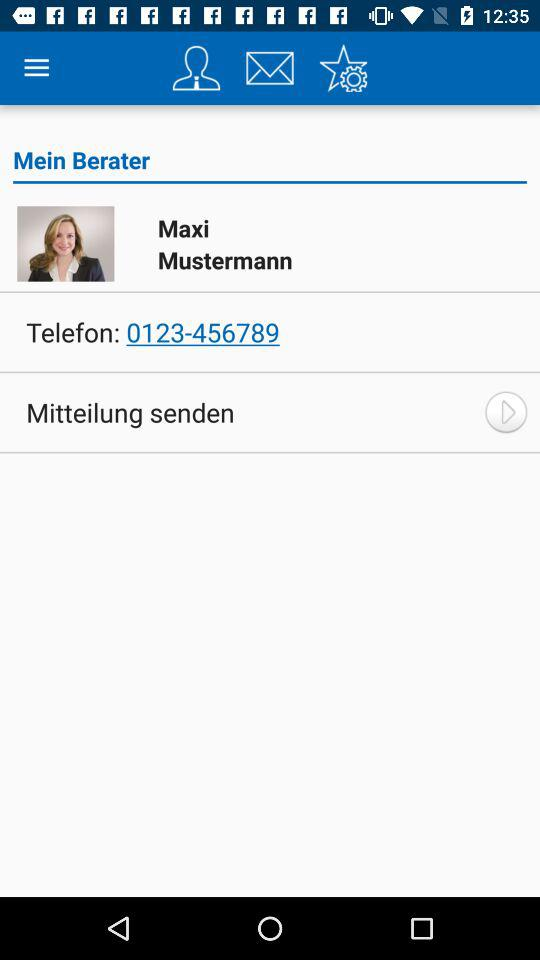How many numbers are there in the phone number?
Answer the question using a single word or phrase. 10 